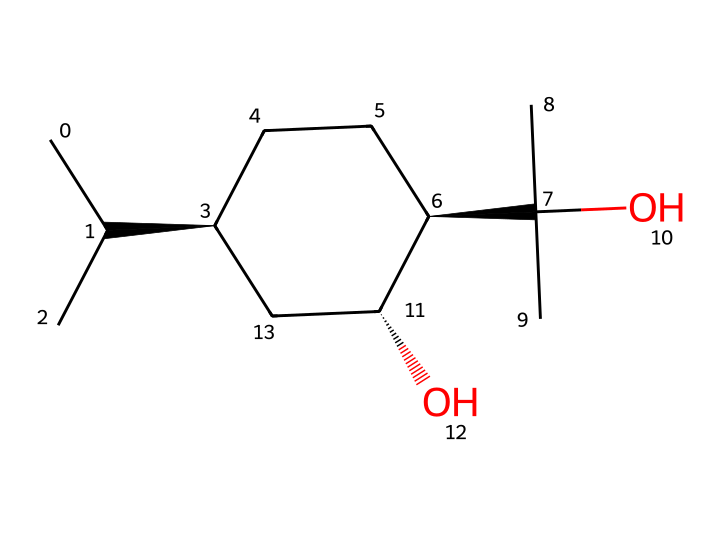What is the chemical name of the compound represented by this SMILES? The SMILES notation given indicates the specific structure and connectivity of the atoms, which corresponds to the chemical name "menthol."
Answer: menthol How many carbon atoms are in the chemical structure? By analyzing the SMILES, we can count the carbon (C) symbols. In this case, there are 10 carbon atoms present in the structure.
Answer: 10 How many hydroxyl (OH) groups are present in this molecule? In the provided SMILES, we can locate the 'O' symbols that are bonded to hydrogen (H) atoms, which indicates hydroxyl groups. There are 2 such O atoms in the structure.
Answer: 2 Which functional group contributes to the cooling sensation? The presence of the hydroxyl (OH) group is responsible for the distinctive cooling sensation of menthol, as it interacts with cold receptors in the skin and mucous membranes.
Answer: hydroxyl group What is the stereochemistry of this menthol structure? The notation "@H" in the SMILES represents chirality centers, indicating that this menthol has specific stereochemical configurations. This structure exhibits two chiral centers.
Answer: two chiral centers How does the branched structure affect the flavor profile of menthol? The branched structure allows for a specific spatial arrangement, enhancing the cooling sensation and minty flavor typical of menthol, making it very effective as a flavor and fragrance component.
Answer: enhances cooling and minty flavor 